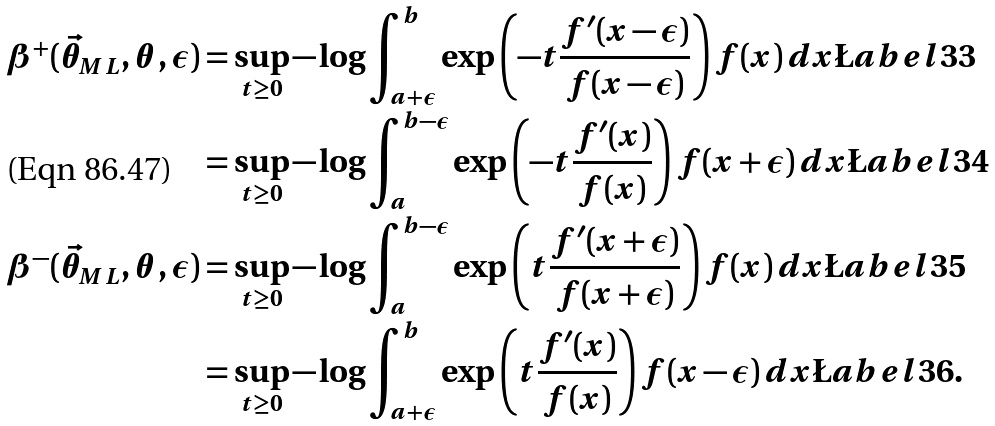Convert formula to latex. <formula><loc_0><loc_0><loc_500><loc_500>\beta ^ { + } ( \vec { \theta } _ { M L } , \theta , \epsilon ) & = \sup _ { t \geq 0 } - \log \int _ { a + \epsilon } ^ { b } \exp \left ( - t \frac { f ^ { \prime } ( x - \epsilon ) } { f ( x - \epsilon ) } \right ) f ( x ) \, d x \L a b e l { 3 3 } \\ & = \sup _ { t \geq 0 } - \log \int _ { a } ^ { b - \epsilon } \exp \left ( - t \frac { f ^ { \prime } ( x ) } { f ( x ) } \right ) f ( x + \epsilon ) \, d x \L a b e l { 3 4 } \\ \beta ^ { - } ( \vec { \theta } _ { M L } , \theta , \epsilon ) & = \sup _ { t \geq 0 } - \log \int _ { a } ^ { b - \epsilon } \exp \left ( t \frac { f ^ { \prime } ( x + \epsilon ) } { f ( x + \epsilon ) } \right ) f ( x ) \, d x \L a b e l { 3 5 } \\ & = \sup _ { t \geq 0 } - \log \int _ { a + \epsilon } ^ { b } \exp \left ( t \frac { f ^ { \prime } ( x ) } { f ( x ) } \right ) f ( x - \epsilon ) \, d x \L a b e l { 3 6 } .</formula> 